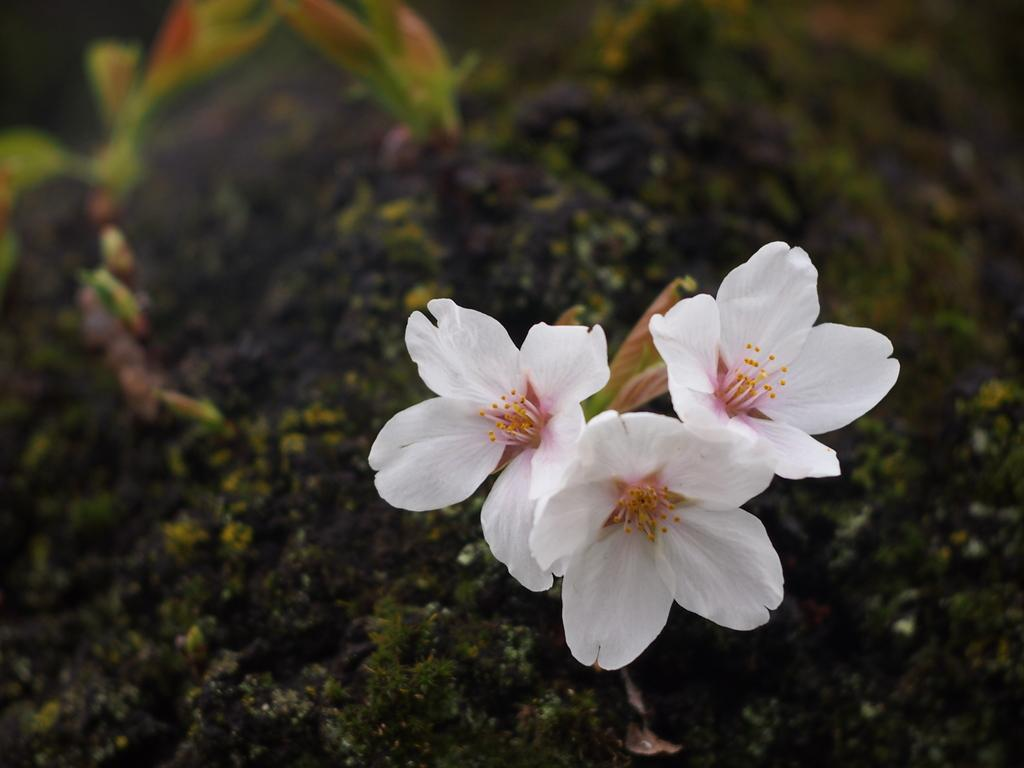What type of vegetation can be seen on the ground in the image? There are plants on the ground in the image. Can you describe any specific features of the plants? There are white-colored flowers on a plant in the image. What type of noise can be heard coming from the flowers in the image? There is no noise coming from the flowers in the image, as flowers do not produce sound. 